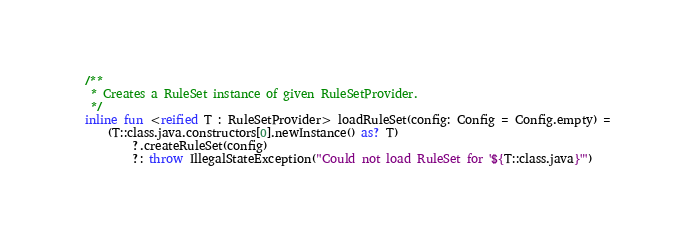<code> <loc_0><loc_0><loc_500><loc_500><_Kotlin_>/**
 * Creates a RuleSet instance of given RuleSetProvider.
 */
inline fun <reified T : RuleSetProvider> loadRuleSet(config: Config = Config.empty) =
    (T::class.java.constructors[0].newInstance() as? T)
        ?.createRuleSet(config)
        ?: throw IllegalStateException("Could not load RuleSet for '${T::class.java}'")
</code> 